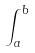<formula> <loc_0><loc_0><loc_500><loc_500>\int _ { a } ^ { b }</formula> 